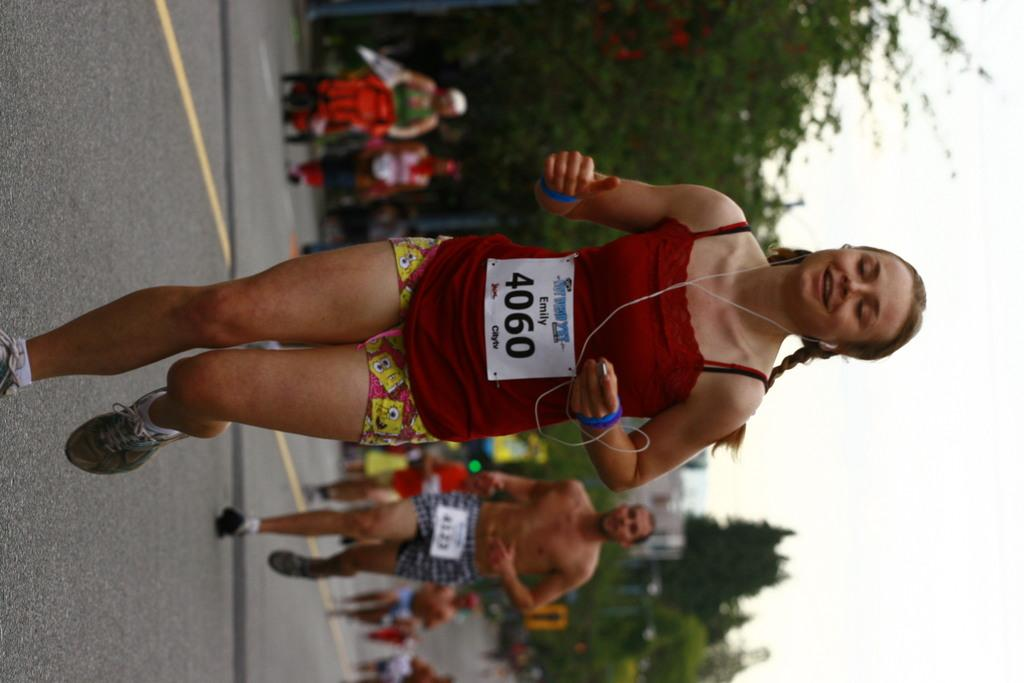Who or what is present in the image? There are people in the image. What are the people doing in the image? The people are running in the image. Where are the people running? The running is taking place on a road. What can be seen in the background of the image? There are trees and the sky visible in the background of the image. What type of copy machine can be seen in the image? There is no copy machine present in the image; it features people running on a road. Can you tell me how many gloves are being worn by the people in the image? There is no mention of gloves in the image; the people are running without any visible gloves. 